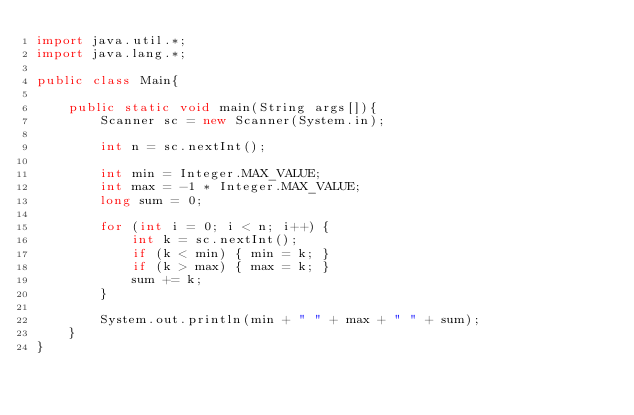Convert code to text. <code><loc_0><loc_0><loc_500><loc_500><_Java_>import java.util.*;
import java.lang.*;

public class Main{
    
    public static void main(String args[]){
        Scanner sc = new Scanner(System.in);
        
        int n = sc.nextInt();
        
        int min = Integer.MAX_VALUE;
        int max = -1 * Integer.MAX_VALUE;
        long sum = 0;
        
        for (int i = 0; i < n; i++) {
            int k = sc.nextInt();
            if (k < min) { min = k; }
            if (k > max) { max = k; }
            sum += k;
        }
        
        System.out.println(min + " " + max + " " + sum);
    }
}
</code> 